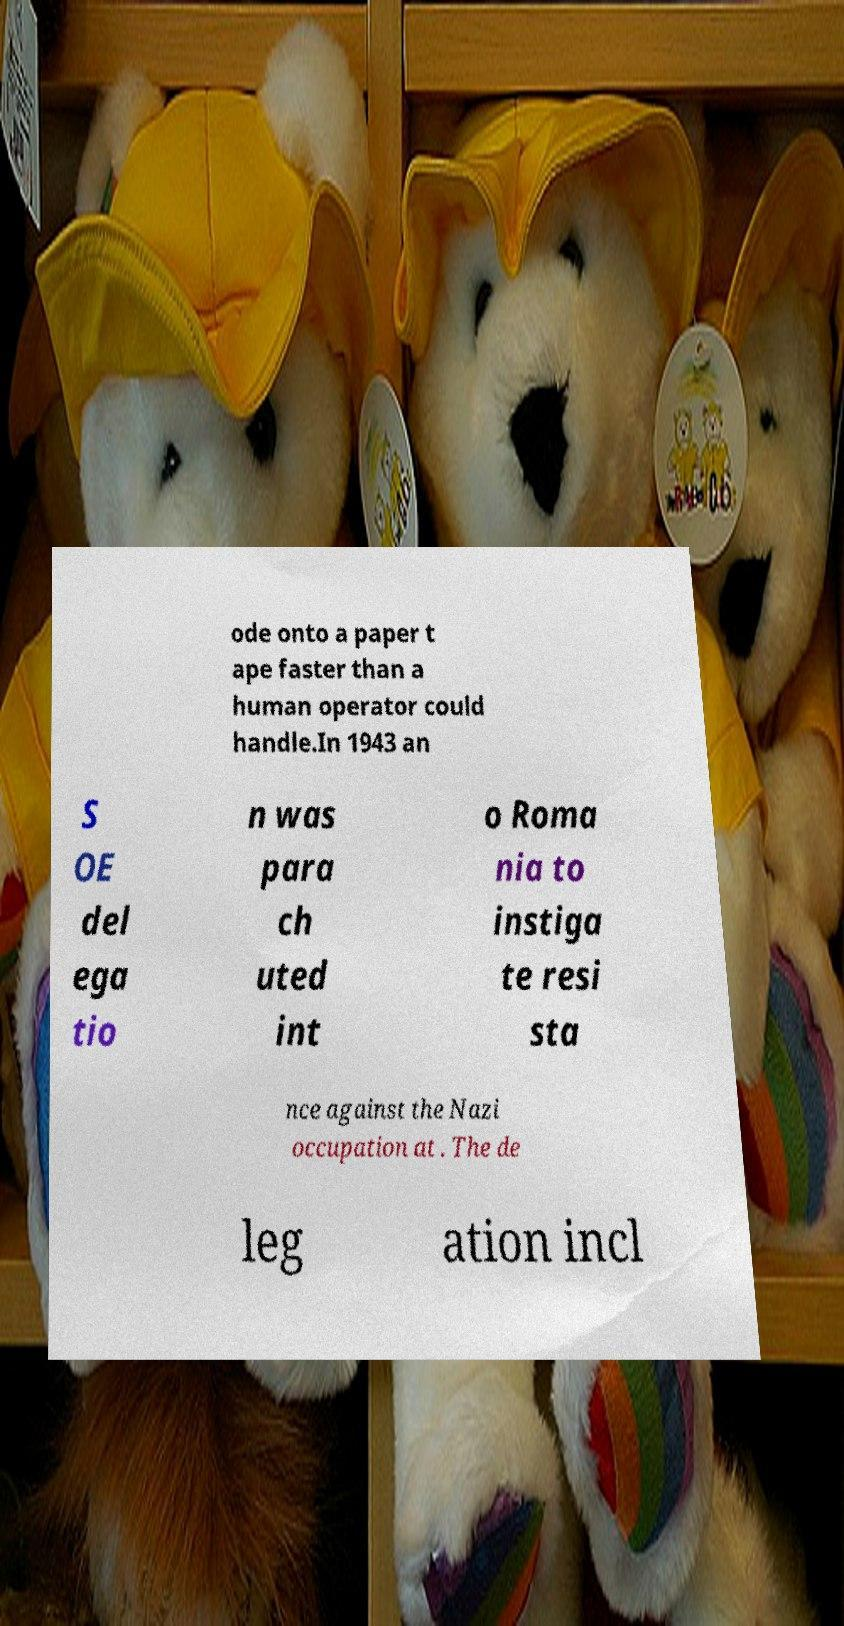Please identify and transcribe the text found in this image. ode onto a paper t ape faster than a human operator could handle.In 1943 an S OE del ega tio n was para ch uted int o Roma nia to instiga te resi sta nce against the Nazi occupation at . The de leg ation incl 